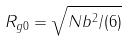Convert formula to latex. <formula><loc_0><loc_0><loc_500><loc_500>R _ { g 0 } = \sqrt { N b ^ { 2 } / ( 6 ) }</formula> 